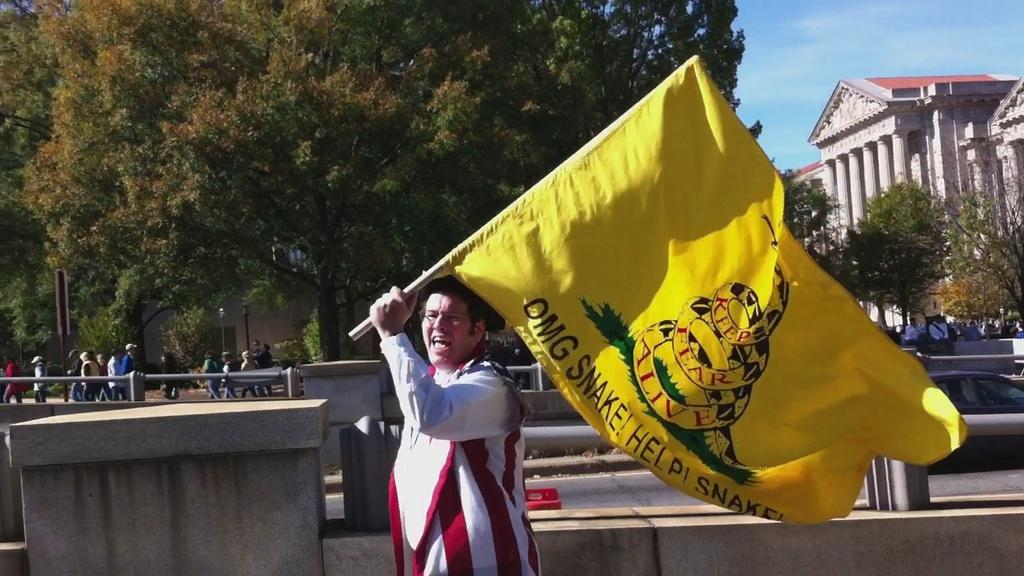<image>
Give a short and clear explanation of the subsequent image. A man carrying a yellow flag with the text 'OMG SNAKE! Help! Snake!'. 